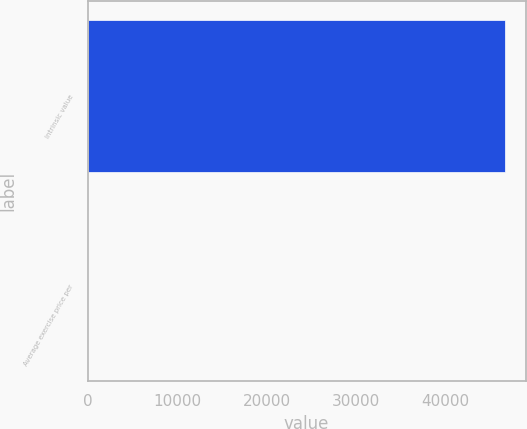<chart> <loc_0><loc_0><loc_500><loc_500><bar_chart><fcel>Intrinsic value<fcel>Average exercise price per<nl><fcel>46592<fcel>24.34<nl></chart> 